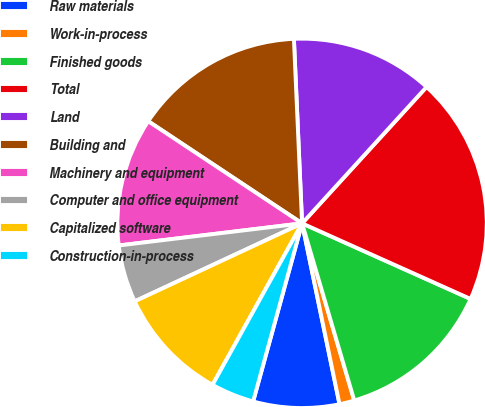Convert chart to OTSL. <chart><loc_0><loc_0><loc_500><loc_500><pie_chart><fcel>Raw materials<fcel>Work-in-process<fcel>Finished goods<fcel>Total<fcel>Land<fcel>Building and<fcel>Machinery and equipment<fcel>Computer and office equipment<fcel>Capitalized software<fcel>Construction-in-process<nl><fcel>7.52%<fcel>1.31%<fcel>13.73%<fcel>19.94%<fcel>12.48%<fcel>14.97%<fcel>11.24%<fcel>5.03%<fcel>10.0%<fcel>3.79%<nl></chart> 